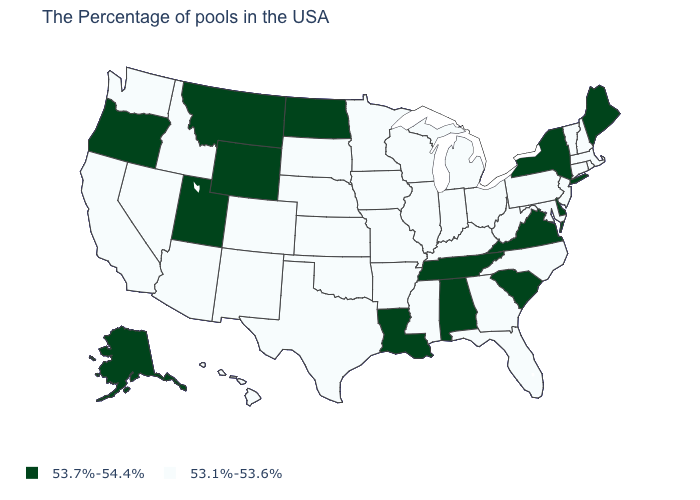Is the legend a continuous bar?
Give a very brief answer. No. Which states have the lowest value in the USA?
Answer briefly. Massachusetts, Rhode Island, New Hampshire, Vermont, Connecticut, New Jersey, Maryland, Pennsylvania, North Carolina, West Virginia, Ohio, Florida, Georgia, Michigan, Kentucky, Indiana, Wisconsin, Illinois, Mississippi, Missouri, Arkansas, Minnesota, Iowa, Kansas, Nebraska, Oklahoma, Texas, South Dakota, Colorado, New Mexico, Arizona, Idaho, Nevada, California, Washington, Hawaii. How many symbols are there in the legend?
Quick response, please. 2. What is the highest value in the USA?
Be succinct. 53.7%-54.4%. What is the value of Nevada?
Short answer required. 53.1%-53.6%. What is the value of Oregon?
Quick response, please. 53.7%-54.4%. What is the value of New York?
Concise answer only. 53.7%-54.4%. What is the value of Alaska?
Keep it brief. 53.7%-54.4%. Name the states that have a value in the range 53.7%-54.4%?
Concise answer only. Maine, New York, Delaware, Virginia, South Carolina, Alabama, Tennessee, Louisiana, North Dakota, Wyoming, Utah, Montana, Oregon, Alaska. What is the highest value in states that border Arkansas?
Concise answer only. 53.7%-54.4%. What is the value of Oregon?
Answer briefly. 53.7%-54.4%. Does the first symbol in the legend represent the smallest category?
Be succinct. No. Does Idaho have a lower value than Florida?
Short answer required. No. What is the lowest value in states that border New York?
Concise answer only. 53.1%-53.6%. What is the highest value in the USA?
Give a very brief answer. 53.7%-54.4%. 